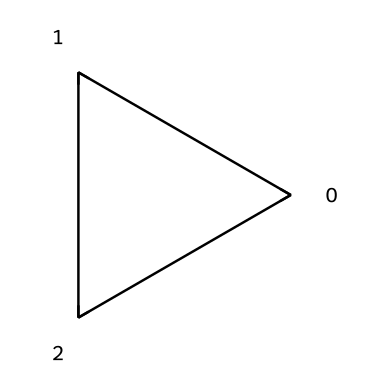What is the molecular formula of cyclopropane? The SMILES representation indicates three carbon atoms and six hydrogen atoms, typical for cyclopropane.
Answer: C3H6 How many carbon atoms are present in cyclopropane? The structure reveals that there are three central carbon atoms forming the cycloalkane ring.
Answer: 3 How many sigma bonds does cyclopropane have? Cyclopropane has three C-C sigma bonds and six C-H sigma bonds, making a total of nine sigma bonds.
Answer: 9 What type of strain is present in the cyclopropane ring? The three-membered ring structure of cyclopropane leads to significant angle strain due to the bond angles being 60 degrees, which is less than the ideal tetrahedral angle of 109.5 degrees.
Answer: angle strain Is cyclopropane a saturated or unsaturated hydrocarbon? The presence of only single bonds between carbon atoms classifies cyclopropane as saturated, meaning it has the maximum number of hydrogen atoms.
Answer: saturated What is the IUPAC name of the compound represented by this SMILES? The SMILES structure corresponds to the three-membered carbon ring with only single bonds, which is officially named cyclopropane according to IUPAC nomenclature.
Answer: cyclopropane Why was cyclopropane used as an anesthetic agent? Cyclopropane was historically used as an anesthetic because it is a potent inhalation agent with rapid induction properties, allowing for quick onset of anesthesia.
Answer: rapid induction 